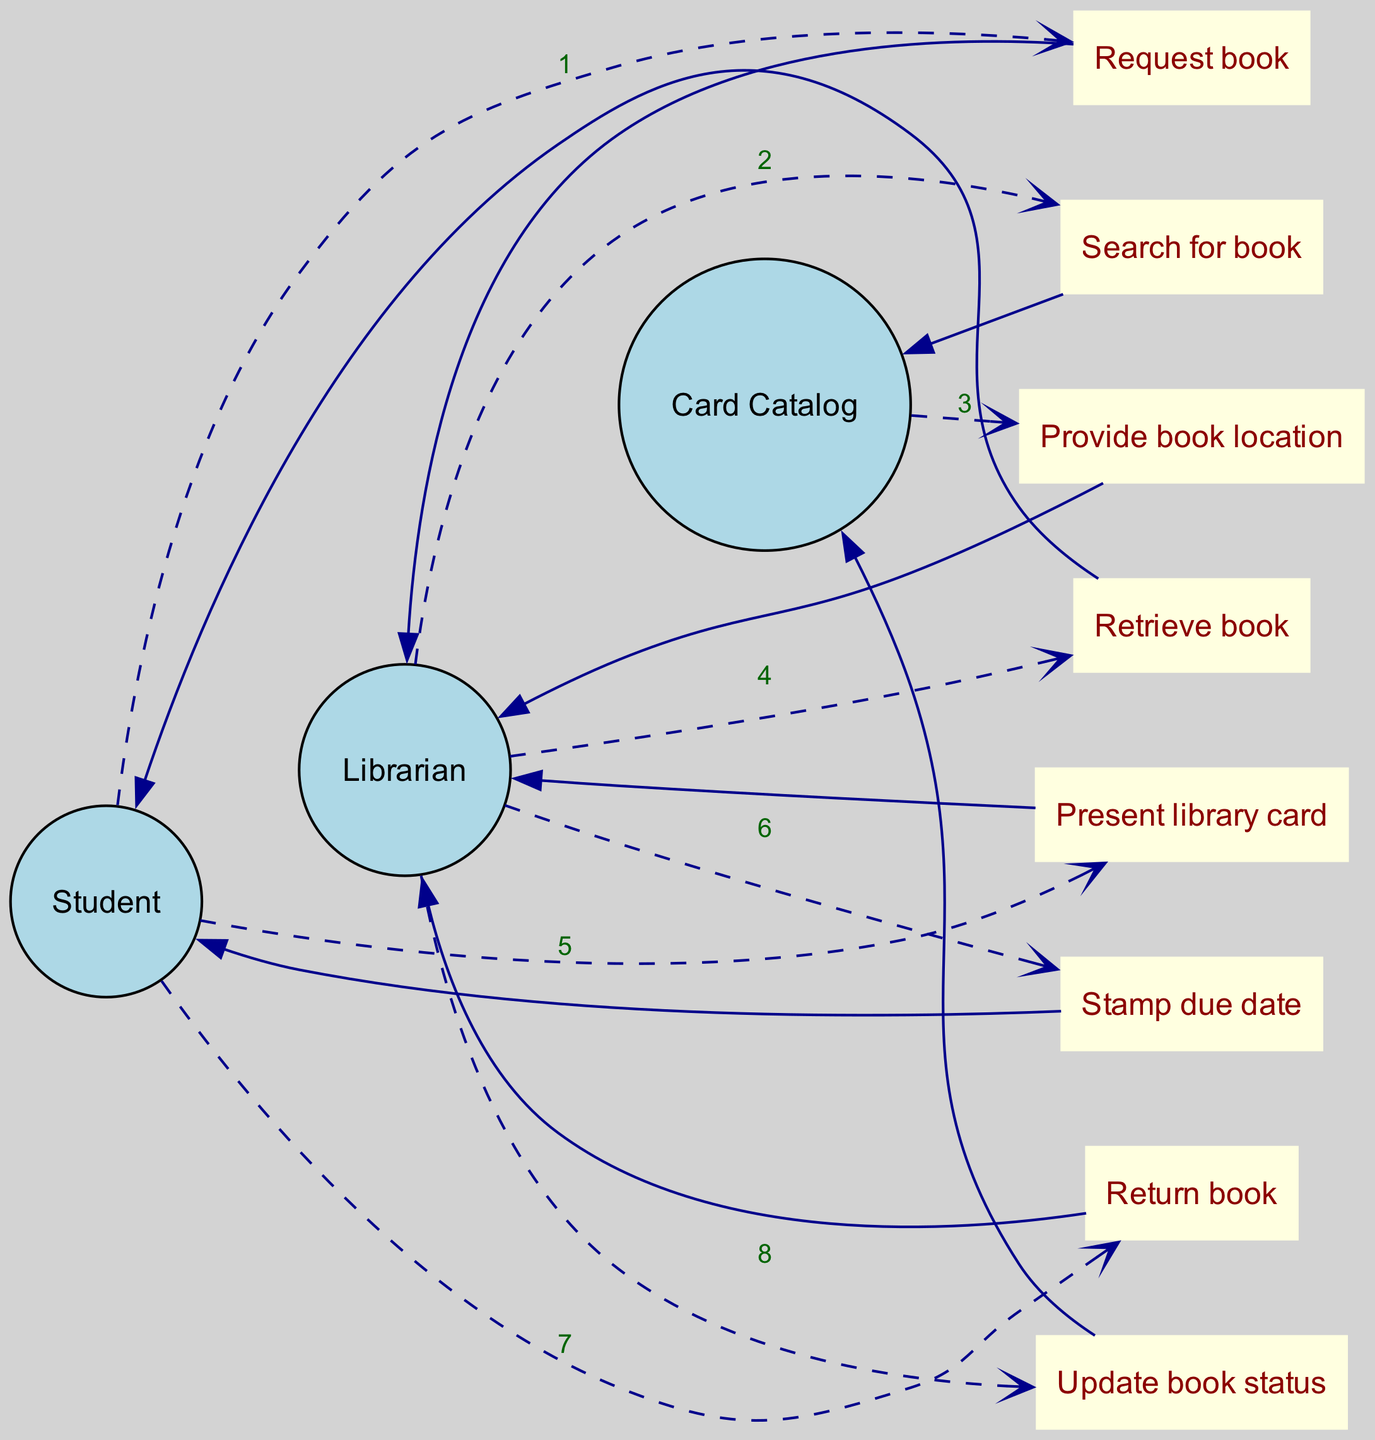What is the first action in the sequence? The first action in the sequence diagram is the "Request book" from the Student to the Librarian, so we identify this as the starting point of the interactions.
Answer: Request book How many actors are involved in the process? By counting the distinct entities in the diagram, we see that there are three actors: Student, Librarian, and Card Catalog. Thus, the total is three.
Answer: 3 What is the last action performed in the sequence? The last action in the sequence is "Update book status," which is performed by the Librarian to the Card Catalog, marking the end of the borrowing and returning process.
Answer: Update book status Which actor presents the library card? In the sequence, the Student presents the library card to the Librarian after retrieving the book. This action clearly shows the Student's role in the process of borrowing a book.
Answer: Student How many actions are there in total? By counting each distinct action communicated between the actors, we identify a total of eight actions in the sequence diagram: Request book, Search for book, Provide book location, Retrieve book, Present library card, Stamp due date, Return book, and Update book status.
Answer: 8 What relationship exists between the Librarian and the Card Catalog during the borrowing process? The relationship is that the Librarian communicates with the Card Catalog to perform a search for the book and subsequently updates the book status after the return, indicating a reliance on the Card Catalog for locating and managing book information.
Answer: Search and Update Who provides the book location in the sequence? The Card Catalog is responsible for providing the book location after the Librarian searches for it, highlighting the support role of the Card Catalog in the process.
Answer: Card Catalog Which action follows the "Return book" action? The action that follows "Return book" is "Update book status," which signifies that after the Student returns the book to the Librarian, the Librarian must then update the status of the book in the Card Catalog.
Answer: Update book status 